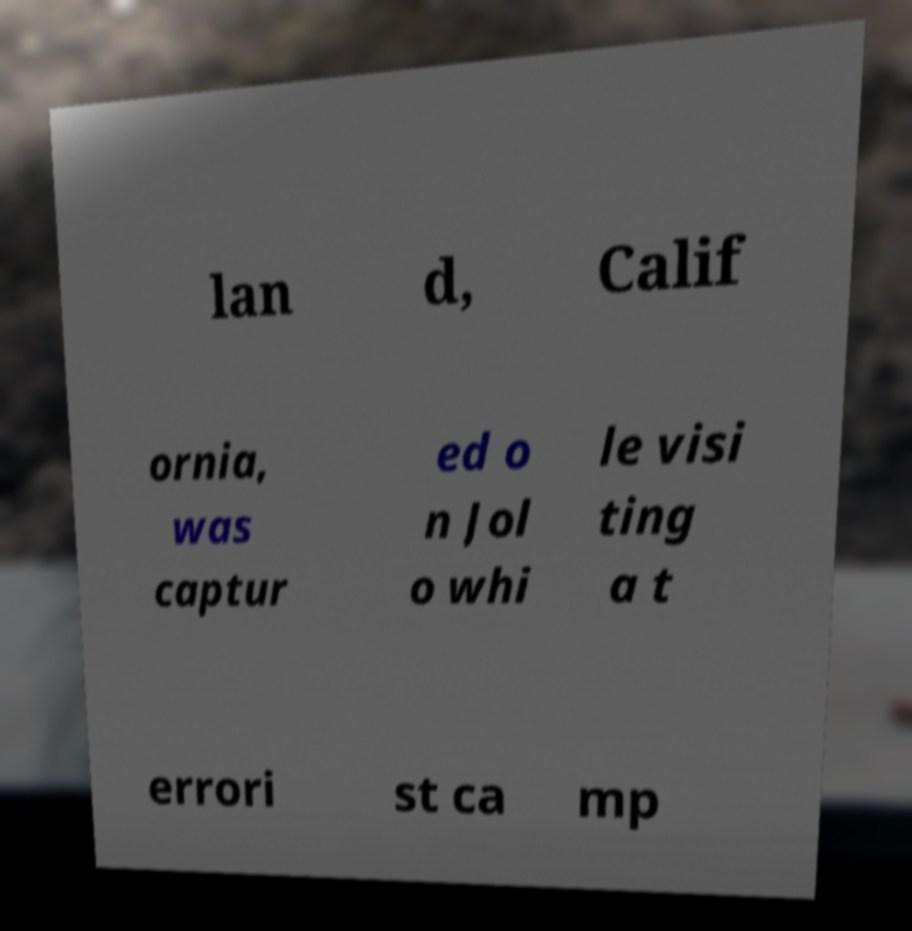Can you accurately transcribe the text from the provided image for me? lan d, Calif ornia, was captur ed o n Jol o whi le visi ting a t errori st ca mp 